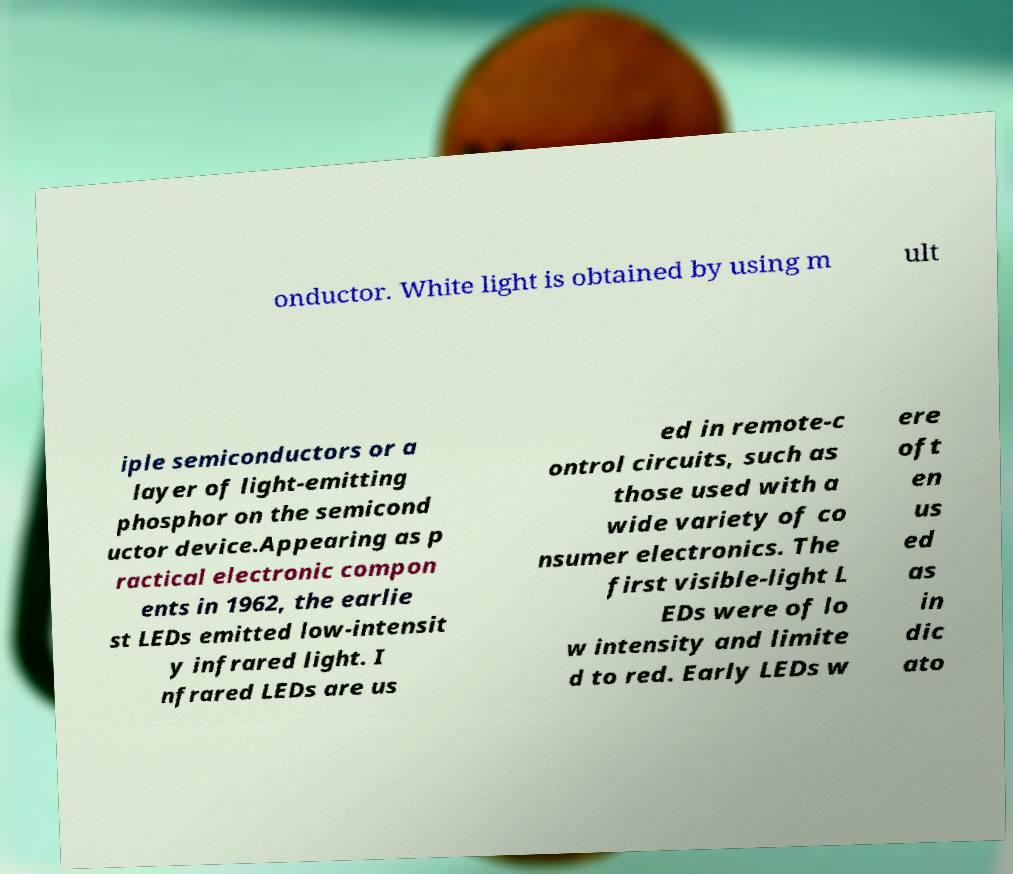Could you extract and type out the text from this image? onductor. White light is obtained by using m ult iple semiconductors or a layer of light-emitting phosphor on the semicond uctor device.Appearing as p ractical electronic compon ents in 1962, the earlie st LEDs emitted low-intensit y infrared light. I nfrared LEDs are us ed in remote-c ontrol circuits, such as those used with a wide variety of co nsumer electronics. The first visible-light L EDs were of lo w intensity and limite d to red. Early LEDs w ere oft en us ed as in dic ato 